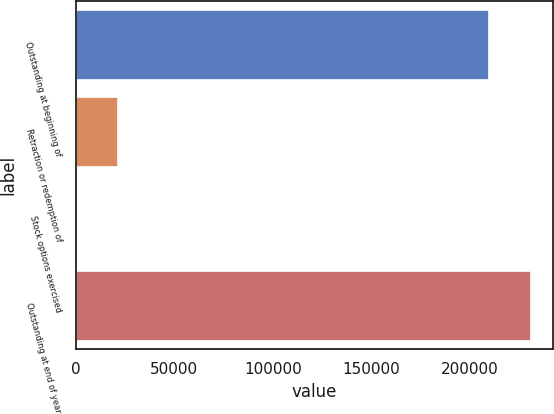<chart> <loc_0><loc_0><loc_500><loc_500><bar_chart><fcel>Outstanding at beginning of<fcel>Retraction or redemption of<fcel>Stock options exercised<fcel>Outstanding at end of year<nl><fcel>209546<fcel>21190.1<fcel>68<fcel>230668<nl></chart> 